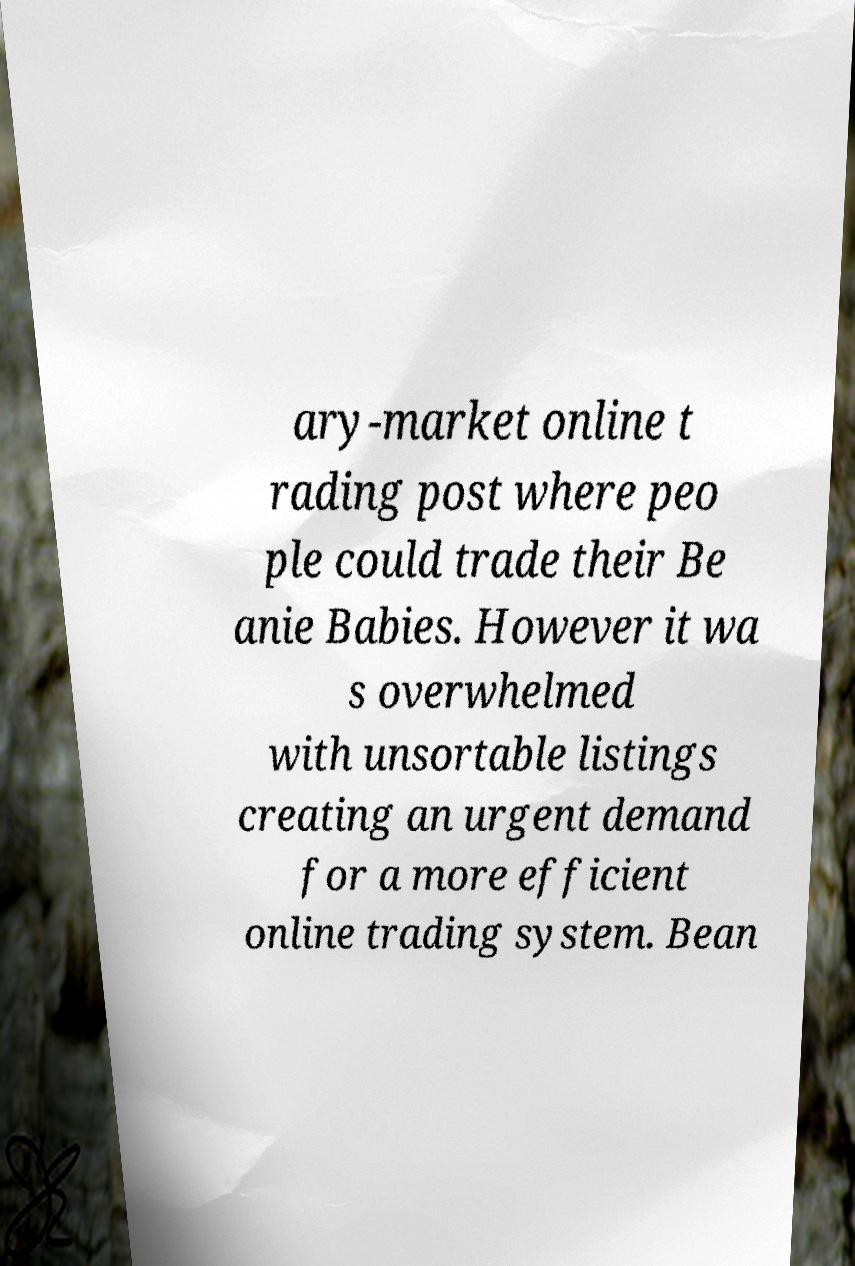Please read and relay the text visible in this image. What does it say? ary-market online t rading post where peo ple could trade their Be anie Babies. However it wa s overwhelmed with unsortable listings creating an urgent demand for a more efficient online trading system. Bean 